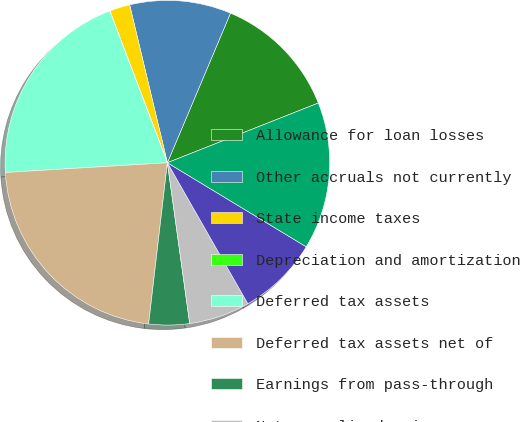<chart> <loc_0><loc_0><loc_500><loc_500><pie_chart><fcel>Allowance for loan losses<fcel>Other accruals not currently<fcel>State income taxes<fcel>Depreciation and amortization<fcel>Deferred tax assets<fcel>Deferred tax assets net of<fcel>Earnings from pass-through<fcel>Net unrealized gain on<fcel>Deferred tax liabilities<fcel>Net deferred tax assets<nl><fcel>12.65%<fcel>10.09%<fcel>2.03%<fcel>0.01%<fcel>20.18%<fcel>22.2%<fcel>4.04%<fcel>6.06%<fcel>8.08%<fcel>14.66%<nl></chart> 